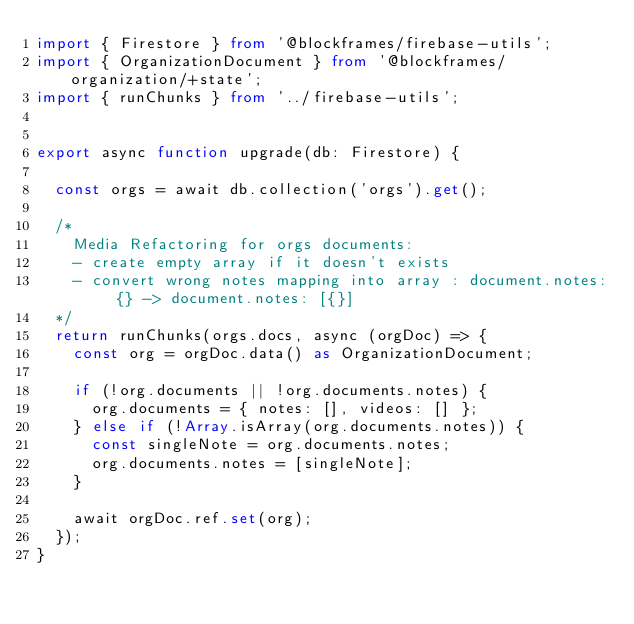Convert code to text. <code><loc_0><loc_0><loc_500><loc_500><_TypeScript_>import { Firestore } from '@blockframes/firebase-utils';
import { OrganizationDocument } from '@blockframes/organization/+state';
import { runChunks } from '../firebase-utils';


export async function upgrade(db: Firestore) {

  const orgs = await db.collection('orgs').get();

  /*
    Media Refactoring for orgs documents:
    - create empty array if it doesn't exists
    - convert wrong notes mapping into array : document.notes: {} -> document.notes: [{}]
  */
  return runChunks(orgs.docs, async (orgDoc) => {
    const org = orgDoc.data() as OrganizationDocument;

    if (!org.documents || !org.documents.notes) {
      org.documents = { notes: [], videos: [] };
    } else if (!Array.isArray(org.documents.notes)) {
      const singleNote = org.documents.notes;
      org.documents.notes = [singleNote];
    }

    await orgDoc.ref.set(org);
  });
}
</code> 